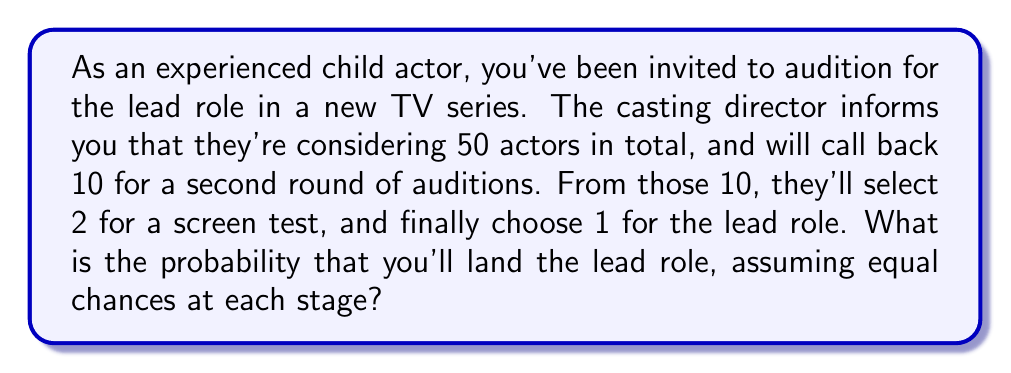What is the answer to this math problem? Let's break this down step-by-step:

1) First, we need to calculate the probability of making it through each stage:

   Stage 1 (Initial audition to callback):
   $P(\text{callback}) = \frac{10}{50} = \frac{1}{5}$

   Stage 2 (Callback to screen test):
   $P(\text{screen test} | \text{callback}) = \frac{2}{10} = \frac{1}{5}$

   Stage 3 (Screen test to lead role):
   $P(\text{lead role} | \text{screen test}) = \frac{1}{2}$

2) To get the overall probability, we multiply these individual probabilities:

   $$P(\text{lead role}) = P(\text{callback}) \times P(\text{screen test} | \text{callback}) \times P(\text{lead role} | \text{screen test})$$

3) Substituting the values:

   $$P(\text{lead role}) = \frac{1}{5} \times \frac{1}{5} \times \frac{1}{2}$$

4) Calculating:

   $$P(\text{lead role}) = \frac{1}{50} = 0.02$$

Therefore, the probability of landing the lead role is 1/50 or 0.02 or 2%.
Answer: $\frac{1}{50}$ or 0.02 or 2% 